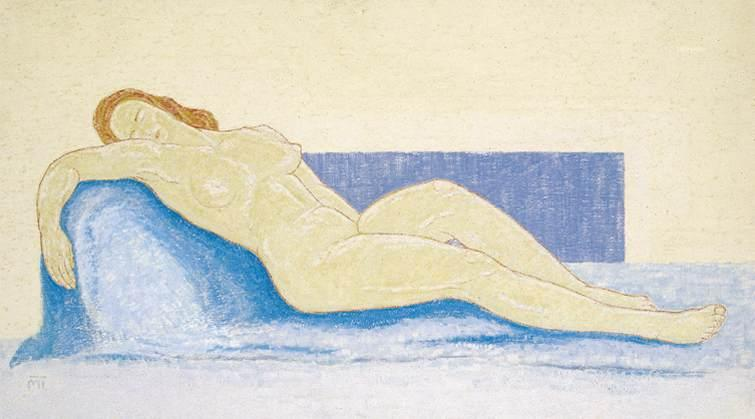If the blue couch could speak, what stories might it tell about the woman and their shared moments together? If the blue couch could speak, it might recount countless quiet afternoons and evenings spent cradling the woman as she rested or lounged. It could tell of the times she stretched out with a book, losing herself in its pages, or of the moments when she simply lay in silence, surrounded by her thoughts. The couch might recall the way her figure would shift and settle, finding the perfect spot to relax. It might mention the faint sounds of her breathing or the soft hums of contentment she often made. The couch and the woman shared a silent companionship, each providing comfort to the other in their own way. 